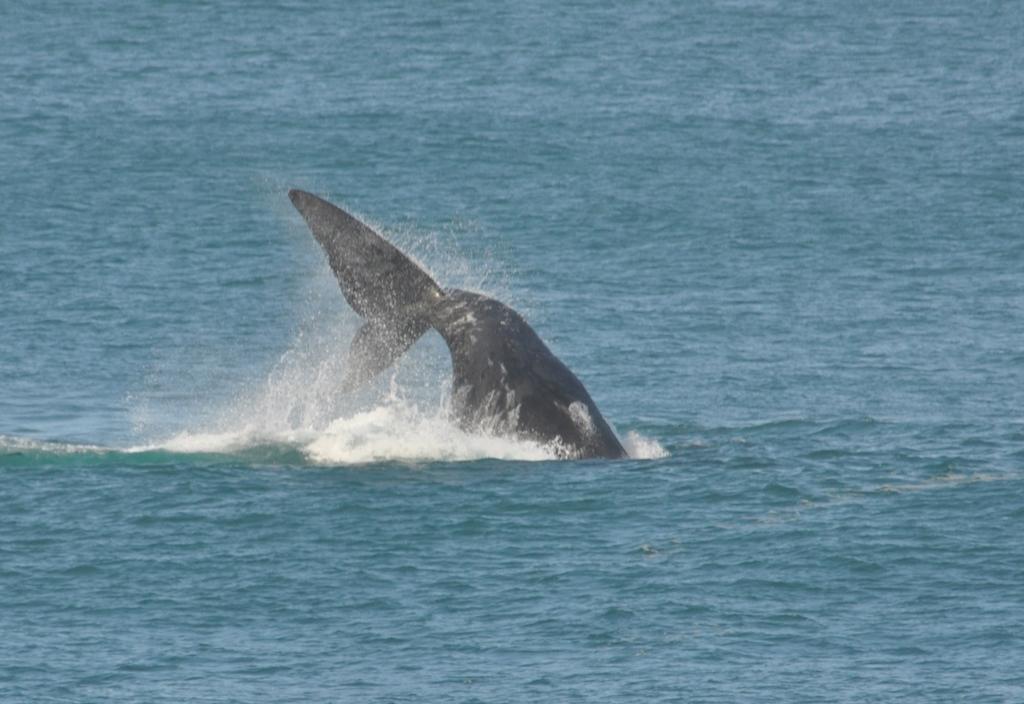Can you describe this image briefly? In this image I can see the aquatic animal in the blue color water. 